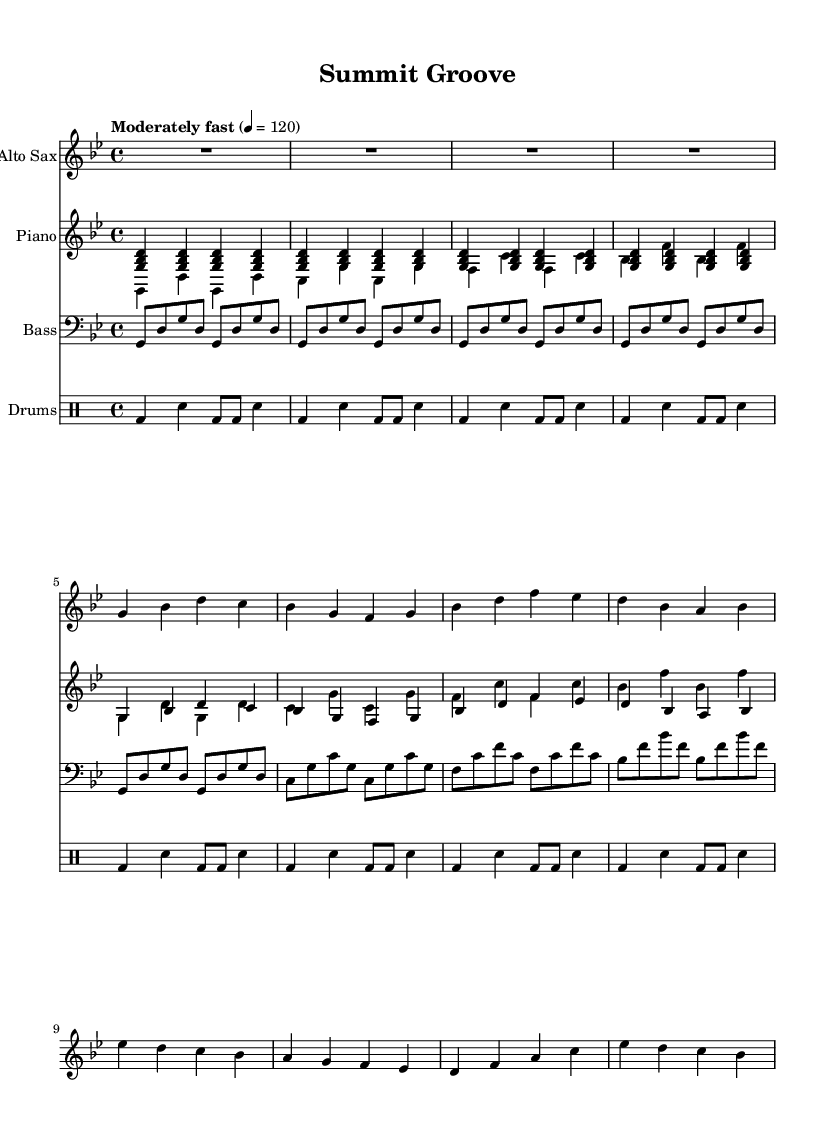What is the key signature of this music? The key signature is indicated by the symbols at the beginning of the staff. In this case, it is G minor, which has two flats (B flat and E flat).
Answer: G minor What is the time signature? The time signature appears at the beginning and indicates the number of beats in a measure. Here, it shows 4/4 time, meaning there are four beats per measure.
Answer: 4/4 What is the tempo marking? The tempo marking provides the speed of the piece. The score states "Moderately fast" with a metronome marking of quarter note = 120, indicating a moderate pace.
Answer: Moderately fast How many measures are in the saxophone part? The measure lines indicate the divisions in the part; counting the measure lines gives the number of measures present. There are 16 measures in total for the saxophone part.
Answer: 16 What type of jazz is represented in this composition? The combination of syncopated rhythms, improvisation potential, and eclectic chord progressions signifies a style unique to the jazz-funk genre. The piece captures a lively and rhythmic feel that is characteristic of jazz-funk.
Answer: Jazz-funk How does the bass line contribute to the overall groove of the piece? The bass line is broken into smaller rhythmic units consisting of eighth notes, which complement the piano's syncopation and provide a solid foundation for the groove. It anchors the harmony effectively while allowing for a swinging rhythm.
Answer: It anchors the groove What is the role of the drums in this composition? The drums in jazz-funk typically include a combination of bass drum and snare rhythm patterns, emphasizing the backbeat. In this piece, the drum part maintains a steady pulse while interacting with accents in the other instruments, shaping the overall feel.
Answer: Maintain pulse and accent 